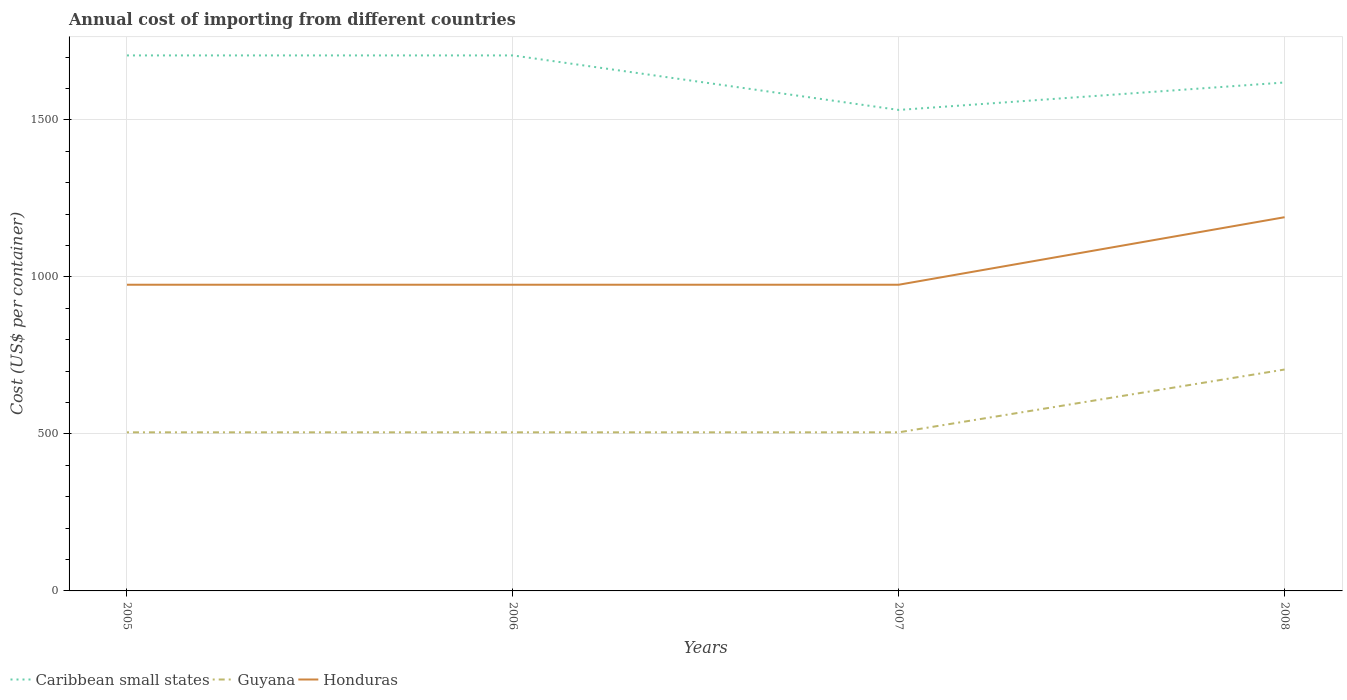How many different coloured lines are there?
Keep it short and to the point. 3. Is the number of lines equal to the number of legend labels?
Make the answer very short. Yes. Across all years, what is the maximum total annual cost of importing in Caribbean small states?
Your answer should be very brief. 1531.58. In which year was the total annual cost of importing in Guyana maximum?
Your answer should be very brief. 2005. What is the total total annual cost of importing in Guyana in the graph?
Make the answer very short. 0. What is the difference between the highest and the second highest total annual cost of importing in Honduras?
Give a very brief answer. 215. Is the total annual cost of importing in Honduras strictly greater than the total annual cost of importing in Caribbean small states over the years?
Provide a succinct answer. Yes. How many lines are there?
Your answer should be very brief. 3. What is the difference between two consecutive major ticks on the Y-axis?
Your answer should be compact. 500. Are the values on the major ticks of Y-axis written in scientific E-notation?
Ensure brevity in your answer.  No. Does the graph contain any zero values?
Your answer should be compact. No. Does the graph contain grids?
Your answer should be very brief. Yes. What is the title of the graph?
Offer a terse response. Annual cost of importing from different countries. What is the label or title of the Y-axis?
Offer a terse response. Cost (US$ per container). What is the Cost (US$ per container) of Caribbean small states in 2005?
Your response must be concise. 1705.18. What is the Cost (US$ per container) of Guyana in 2005?
Make the answer very short. 505. What is the Cost (US$ per container) of Honduras in 2005?
Provide a succinct answer. 975. What is the Cost (US$ per container) of Caribbean small states in 2006?
Offer a very short reply. 1705.18. What is the Cost (US$ per container) in Guyana in 2006?
Your response must be concise. 505. What is the Cost (US$ per container) of Honduras in 2006?
Offer a very short reply. 975. What is the Cost (US$ per container) of Caribbean small states in 2007?
Ensure brevity in your answer.  1531.58. What is the Cost (US$ per container) in Guyana in 2007?
Offer a very short reply. 505. What is the Cost (US$ per container) of Honduras in 2007?
Your answer should be very brief. 975. What is the Cost (US$ per container) of Caribbean small states in 2008?
Your response must be concise. 1619. What is the Cost (US$ per container) in Guyana in 2008?
Offer a terse response. 705. What is the Cost (US$ per container) of Honduras in 2008?
Ensure brevity in your answer.  1190. Across all years, what is the maximum Cost (US$ per container) of Caribbean small states?
Offer a very short reply. 1705.18. Across all years, what is the maximum Cost (US$ per container) in Guyana?
Give a very brief answer. 705. Across all years, what is the maximum Cost (US$ per container) in Honduras?
Provide a succinct answer. 1190. Across all years, what is the minimum Cost (US$ per container) of Caribbean small states?
Your response must be concise. 1531.58. Across all years, what is the minimum Cost (US$ per container) of Guyana?
Make the answer very short. 505. Across all years, what is the minimum Cost (US$ per container) in Honduras?
Offer a very short reply. 975. What is the total Cost (US$ per container) in Caribbean small states in the graph?
Offer a terse response. 6560.95. What is the total Cost (US$ per container) of Guyana in the graph?
Provide a short and direct response. 2220. What is the total Cost (US$ per container) of Honduras in the graph?
Provide a short and direct response. 4115. What is the difference between the Cost (US$ per container) of Caribbean small states in 2005 and that in 2006?
Offer a very short reply. 0. What is the difference between the Cost (US$ per container) in Guyana in 2005 and that in 2006?
Offer a terse response. 0. What is the difference between the Cost (US$ per container) of Honduras in 2005 and that in 2006?
Provide a succinct answer. 0. What is the difference between the Cost (US$ per container) in Caribbean small states in 2005 and that in 2007?
Your answer should be very brief. 173.6. What is the difference between the Cost (US$ per container) of Caribbean small states in 2005 and that in 2008?
Make the answer very short. 86.18. What is the difference between the Cost (US$ per container) of Guyana in 2005 and that in 2008?
Keep it short and to the point. -200. What is the difference between the Cost (US$ per container) in Honduras in 2005 and that in 2008?
Keep it short and to the point. -215. What is the difference between the Cost (US$ per container) of Caribbean small states in 2006 and that in 2007?
Provide a short and direct response. 173.6. What is the difference between the Cost (US$ per container) in Caribbean small states in 2006 and that in 2008?
Provide a succinct answer. 86.18. What is the difference between the Cost (US$ per container) in Guyana in 2006 and that in 2008?
Provide a succinct answer. -200. What is the difference between the Cost (US$ per container) of Honduras in 2006 and that in 2008?
Provide a succinct answer. -215. What is the difference between the Cost (US$ per container) in Caribbean small states in 2007 and that in 2008?
Provide a short and direct response. -87.42. What is the difference between the Cost (US$ per container) in Guyana in 2007 and that in 2008?
Provide a succinct answer. -200. What is the difference between the Cost (US$ per container) of Honduras in 2007 and that in 2008?
Your answer should be compact. -215. What is the difference between the Cost (US$ per container) in Caribbean small states in 2005 and the Cost (US$ per container) in Guyana in 2006?
Offer a very short reply. 1200.18. What is the difference between the Cost (US$ per container) of Caribbean small states in 2005 and the Cost (US$ per container) of Honduras in 2006?
Offer a terse response. 730.18. What is the difference between the Cost (US$ per container) in Guyana in 2005 and the Cost (US$ per container) in Honduras in 2006?
Provide a succinct answer. -470. What is the difference between the Cost (US$ per container) of Caribbean small states in 2005 and the Cost (US$ per container) of Guyana in 2007?
Provide a short and direct response. 1200.18. What is the difference between the Cost (US$ per container) of Caribbean small states in 2005 and the Cost (US$ per container) of Honduras in 2007?
Provide a succinct answer. 730.18. What is the difference between the Cost (US$ per container) in Guyana in 2005 and the Cost (US$ per container) in Honduras in 2007?
Make the answer very short. -470. What is the difference between the Cost (US$ per container) of Caribbean small states in 2005 and the Cost (US$ per container) of Guyana in 2008?
Offer a terse response. 1000.18. What is the difference between the Cost (US$ per container) of Caribbean small states in 2005 and the Cost (US$ per container) of Honduras in 2008?
Your answer should be compact. 515.18. What is the difference between the Cost (US$ per container) in Guyana in 2005 and the Cost (US$ per container) in Honduras in 2008?
Offer a very short reply. -685. What is the difference between the Cost (US$ per container) in Caribbean small states in 2006 and the Cost (US$ per container) in Guyana in 2007?
Offer a very short reply. 1200.18. What is the difference between the Cost (US$ per container) of Caribbean small states in 2006 and the Cost (US$ per container) of Honduras in 2007?
Ensure brevity in your answer.  730.18. What is the difference between the Cost (US$ per container) of Guyana in 2006 and the Cost (US$ per container) of Honduras in 2007?
Give a very brief answer. -470. What is the difference between the Cost (US$ per container) of Caribbean small states in 2006 and the Cost (US$ per container) of Guyana in 2008?
Offer a very short reply. 1000.18. What is the difference between the Cost (US$ per container) of Caribbean small states in 2006 and the Cost (US$ per container) of Honduras in 2008?
Give a very brief answer. 515.18. What is the difference between the Cost (US$ per container) of Guyana in 2006 and the Cost (US$ per container) of Honduras in 2008?
Offer a terse response. -685. What is the difference between the Cost (US$ per container) of Caribbean small states in 2007 and the Cost (US$ per container) of Guyana in 2008?
Ensure brevity in your answer.  826.58. What is the difference between the Cost (US$ per container) in Caribbean small states in 2007 and the Cost (US$ per container) in Honduras in 2008?
Offer a terse response. 341.58. What is the difference between the Cost (US$ per container) of Guyana in 2007 and the Cost (US$ per container) of Honduras in 2008?
Make the answer very short. -685. What is the average Cost (US$ per container) in Caribbean small states per year?
Offer a terse response. 1640.24. What is the average Cost (US$ per container) of Guyana per year?
Ensure brevity in your answer.  555. What is the average Cost (US$ per container) of Honduras per year?
Provide a short and direct response. 1028.75. In the year 2005, what is the difference between the Cost (US$ per container) in Caribbean small states and Cost (US$ per container) in Guyana?
Offer a very short reply. 1200.18. In the year 2005, what is the difference between the Cost (US$ per container) in Caribbean small states and Cost (US$ per container) in Honduras?
Your answer should be very brief. 730.18. In the year 2005, what is the difference between the Cost (US$ per container) in Guyana and Cost (US$ per container) in Honduras?
Your response must be concise. -470. In the year 2006, what is the difference between the Cost (US$ per container) of Caribbean small states and Cost (US$ per container) of Guyana?
Your answer should be very brief. 1200.18. In the year 2006, what is the difference between the Cost (US$ per container) of Caribbean small states and Cost (US$ per container) of Honduras?
Offer a very short reply. 730.18. In the year 2006, what is the difference between the Cost (US$ per container) of Guyana and Cost (US$ per container) of Honduras?
Your response must be concise. -470. In the year 2007, what is the difference between the Cost (US$ per container) of Caribbean small states and Cost (US$ per container) of Guyana?
Make the answer very short. 1026.58. In the year 2007, what is the difference between the Cost (US$ per container) in Caribbean small states and Cost (US$ per container) in Honduras?
Offer a very short reply. 556.58. In the year 2007, what is the difference between the Cost (US$ per container) of Guyana and Cost (US$ per container) of Honduras?
Your answer should be very brief. -470. In the year 2008, what is the difference between the Cost (US$ per container) of Caribbean small states and Cost (US$ per container) of Guyana?
Ensure brevity in your answer.  914. In the year 2008, what is the difference between the Cost (US$ per container) of Caribbean small states and Cost (US$ per container) of Honduras?
Ensure brevity in your answer.  429. In the year 2008, what is the difference between the Cost (US$ per container) of Guyana and Cost (US$ per container) of Honduras?
Your answer should be compact. -485. What is the ratio of the Cost (US$ per container) in Guyana in 2005 to that in 2006?
Make the answer very short. 1. What is the ratio of the Cost (US$ per container) in Caribbean small states in 2005 to that in 2007?
Provide a succinct answer. 1.11. What is the ratio of the Cost (US$ per container) in Guyana in 2005 to that in 2007?
Your response must be concise. 1. What is the ratio of the Cost (US$ per container) in Honduras in 2005 to that in 2007?
Your response must be concise. 1. What is the ratio of the Cost (US$ per container) in Caribbean small states in 2005 to that in 2008?
Your response must be concise. 1.05. What is the ratio of the Cost (US$ per container) of Guyana in 2005 to that in 2008?
Your answer should be very brief. 0.72. What is the ratio of the Cost (US$ per container) of Honduras in 2005 to that in 2008?
Your answer should be very brief. 0.82. What is the ratio of the Cost (US$ per container) of Caribbean small states in 2006 to that in 2007?
Provide a succinct answer. 1.11. What is the ratio of the Cost (US$ per container) in Caribbean small states in 2006 to that in 2008?
Make the answer very short. 1.05. What is the ratio of the Cost (US$ per container) of Guyana in 2006 to that in 2008?
Keep it short and to the point. 0.72. What is the ratio of the Cost (US$ per container) of Honduras in 2006 to that in 2008?
Provide a short and direct response. 0.82. What is the ratio of the Cost (US$ per container) in Caribbean small states in 2007 to that in 2008?
Offer a terse response. 0.95. What is the ratio of the Cost (US$ per container) of Guyana in 2007 to that in 2008?
Make the answer very short. 0.72. What is the ratio of the Cost (US$ per container) in Honduras in 2007 to that in 2008?
Give a very brief answer. 0.82. What is the difference between the highest and the second highest Cost (US$ per container) of Honduras?
Offer a very short reply. 215. What is the difference between the highest and the lowest Cost (US$ per container) in Caribbean small states?
Give a very brief answer. 173.6. What is the difference between the highest and the lowest Cost (US$ per container) of Honduras?
Offer a very short reply. 215. 